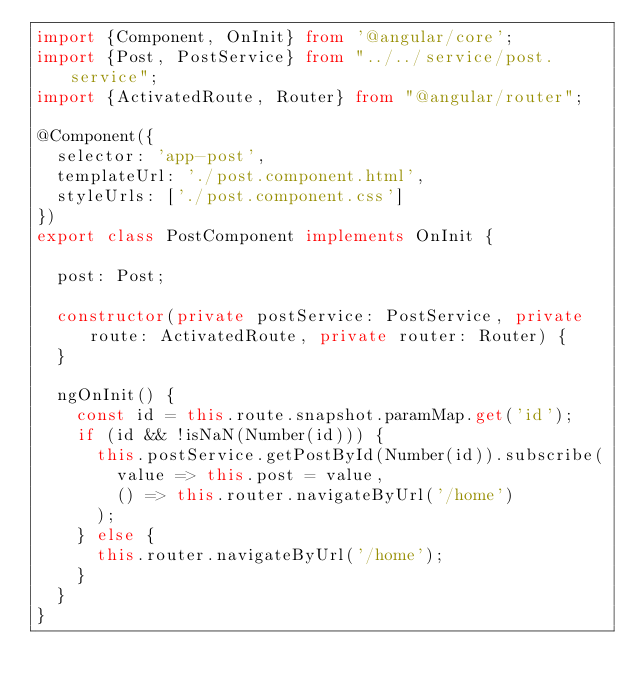Convert code to text. <code><loc_0><loc_0><loc_500><loc_500><_TypeScript_>import {Component, OnInit} from '@angular/core';
import {Post, PostService} from "../../service/post.service";
import {ActivatedRoute, Router} from "@angular/router";

@Component({
  selector: 'app-post',
  templateUrl: './post.component.html',
  styleUrls: ['./post.component.css']
})
export class PostComponent implements OnInit {

  post: Post;

  constructor(private postService: PostService, private route: ActivatedRoute, private router: Router) {
  }

  ngOnInit() {
    const id = this.route.snapshot.paramMap.get('id');
    if (id && !isNaN(Number(id))) {
      this.postService.getPostById(Number(id)).subscribe(
        value => this.post = value,
        () => this.router.navigateByUrl('/home')
      );
    } else {
      this.router.navigateByUrl('/home');
    }
  }
}
</code> 